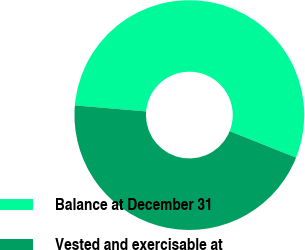Convert chart. <chart><loc_0><loc_0><loc_500><loc_500><pie_chart><fcel>Balance at December 31<fcel>Vested and exercisable at<nl><fcel>54.7%<fcel>45.3%<nl></chart> 